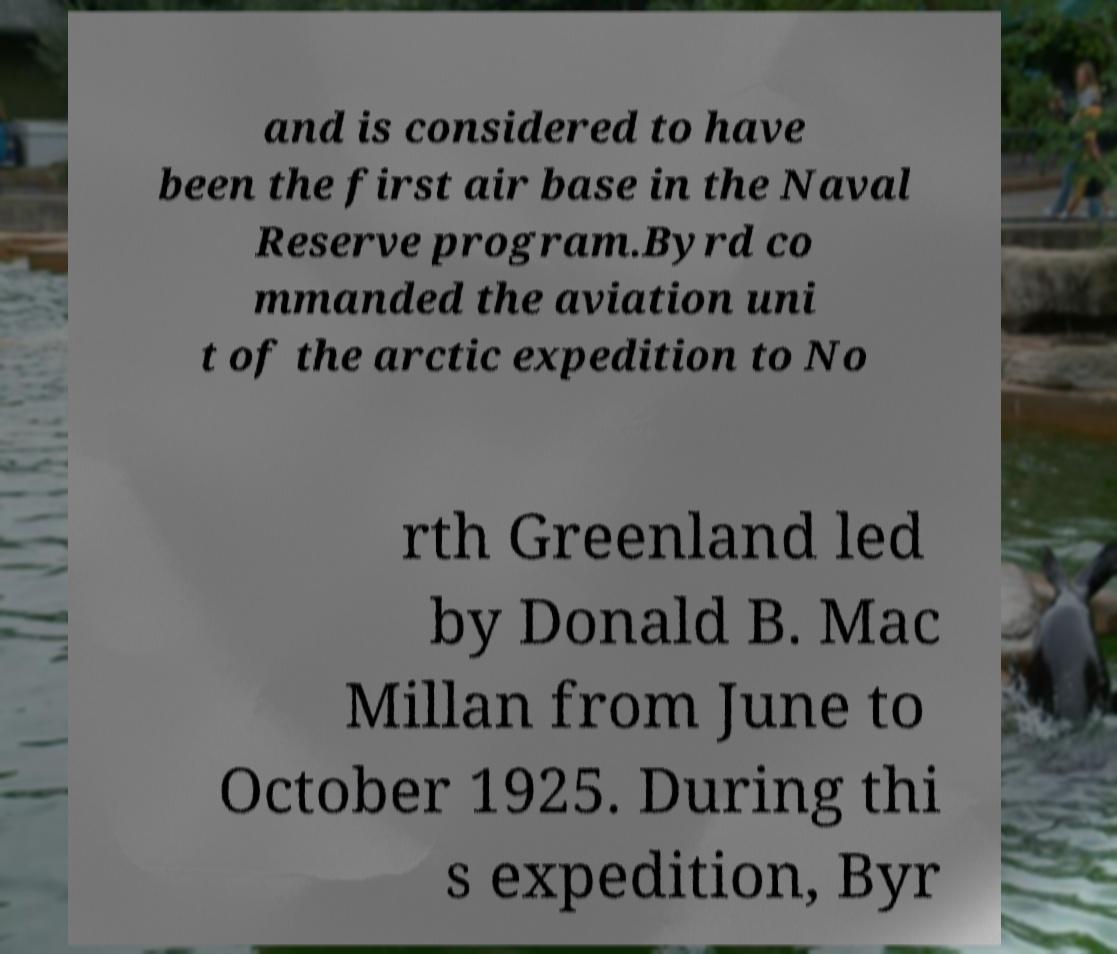Please identify and transcribe the text found in this image. and is considered to have been the first air base in the Naval Reserve program.Byrd co mmanded the aviation uni t of the arctic expedition to No rth Greenland led by Donald B. Mac Millan from June to October 1925. During thi s expedition, Byr 